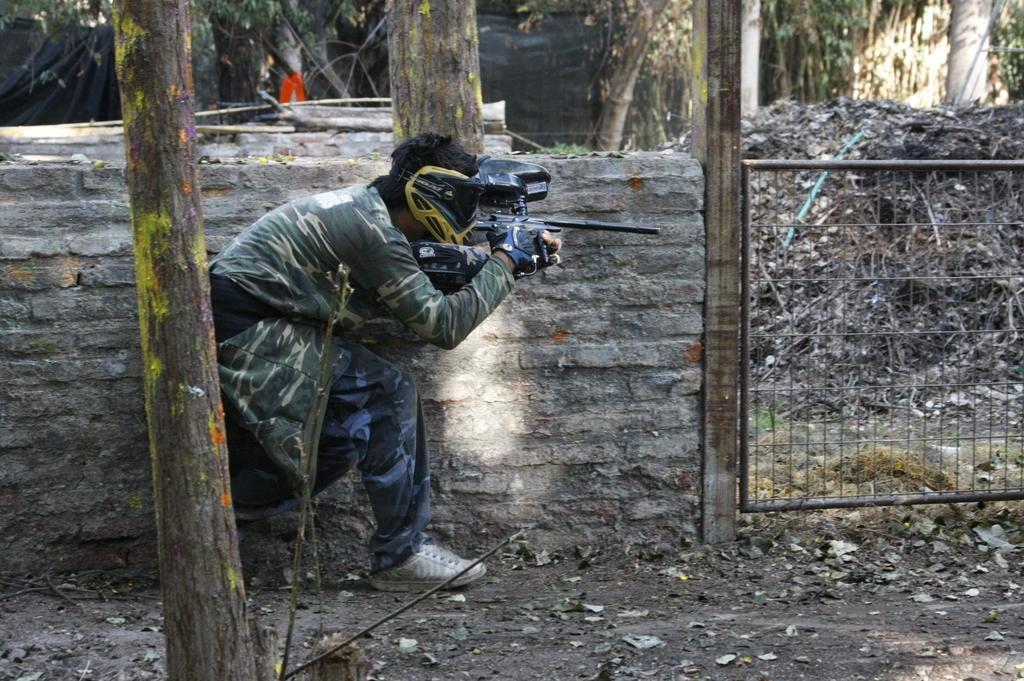How would you summarize this image in a sentence or two? In the given image i can see a person holding a gun,fence,wooden trunks and trees. 